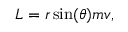<formula> <loc_0><loc_0><loc_500><loc_500>L = r \sin ( \theta ) m v ,</formula> 